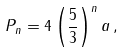Convert formula to latex. <formula><loc_0><loc_0><loc_500><loc_500>P _ { n } = 4 \left ( { \frac { 5 } { 3 } } \right ) ^ { n } a \, ,</formula> 